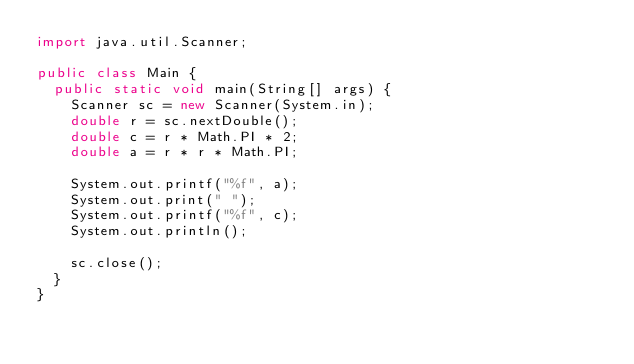<code> <loc_0><loc_0><loc_500><loc_500><_Java_>import java.util.Scanner;

public class Main {
	public static void main(String[] args) {
		Scanner sc = new Scanner(System.in);
		double r = sc.nextDouble();
		double c = r * Math.PI * 2;
		double a = r * r * Math.PI;

		System.out.printf("%f", a);
		System.out.print(" ");
		System.out.printf("%f", c);
		System.out.println();

		sc.close();
	}
}

</code> 